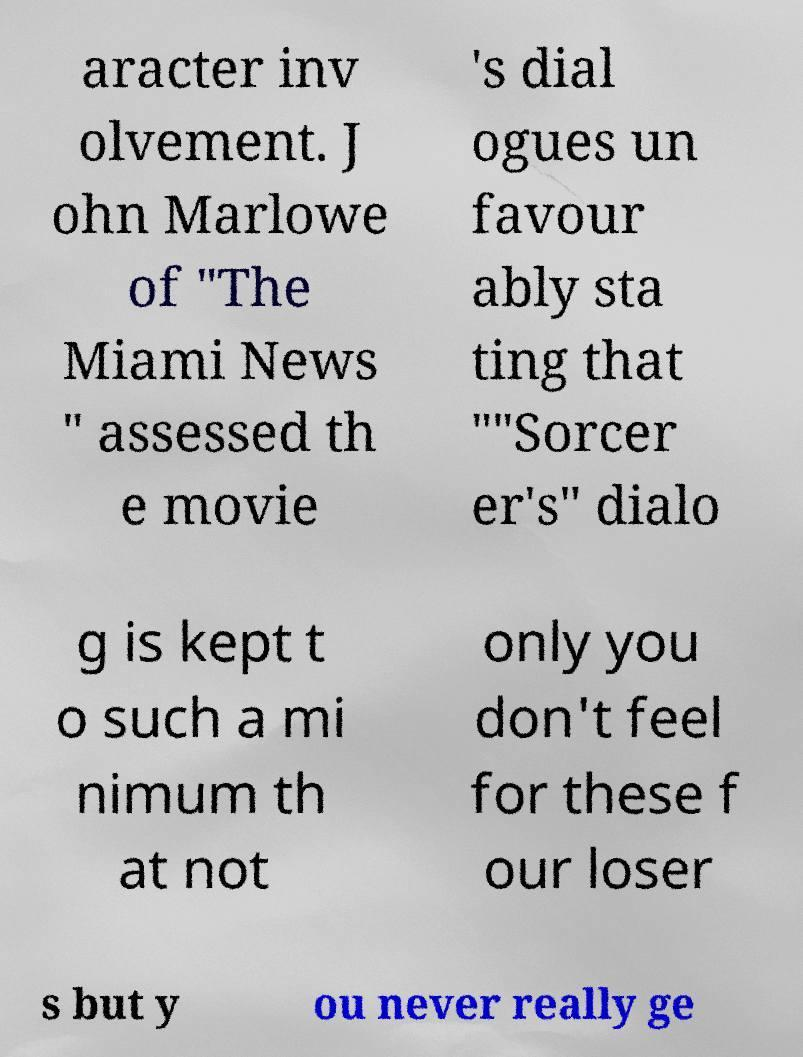I need the written content from this picture converted into text. Can you do that? aracter inv olvement. J ohn Marlowe of "The Miami News " assessed th e movie 's dial ogues un favour ably sta ting that ""Sorcer er's" dialo g is kept t o such a mi nimum th at not only you don't feel for these f our loser s but y ou never really ge 